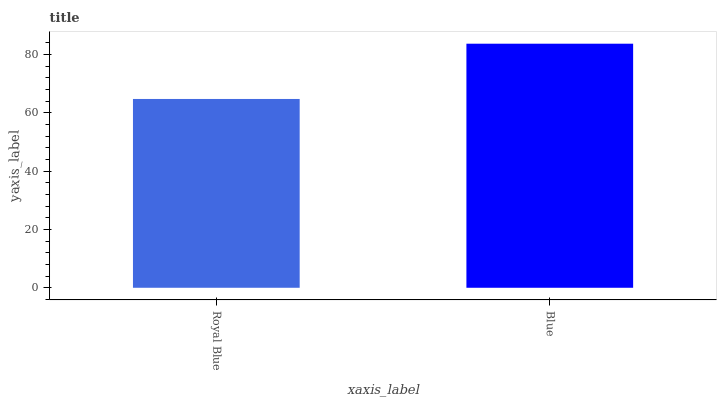Is Royal Blue the minimum?
Answer yes or no. Yes. Is Blue the maximum?
Answer yes or no. Yes. Is Blue the minimum?
Answer yes or no. No. Is Blue greater than Royal Blue?
Answer yes or no. Yes. Is Royal Blue less than Blue?
Answer yes or no. Yes. Is Royal Blue greater than Blue?
Answer yes or no. No. Is Blue less than Royal Blue?
Answer yes or no. No. Is Blue the high median?
Answer yes or no. Yes. Is Royal Blue the low median?
Answer yes or no. Yes. Is Royal Blue the high median?
Answer yes or no. No. Is Blue the low median?
Answer yes or no. No. 